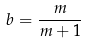<formula> <loc_0><loc_0><loc_500><loc_500>b = \frac { m } { m + 1 }</formula> 